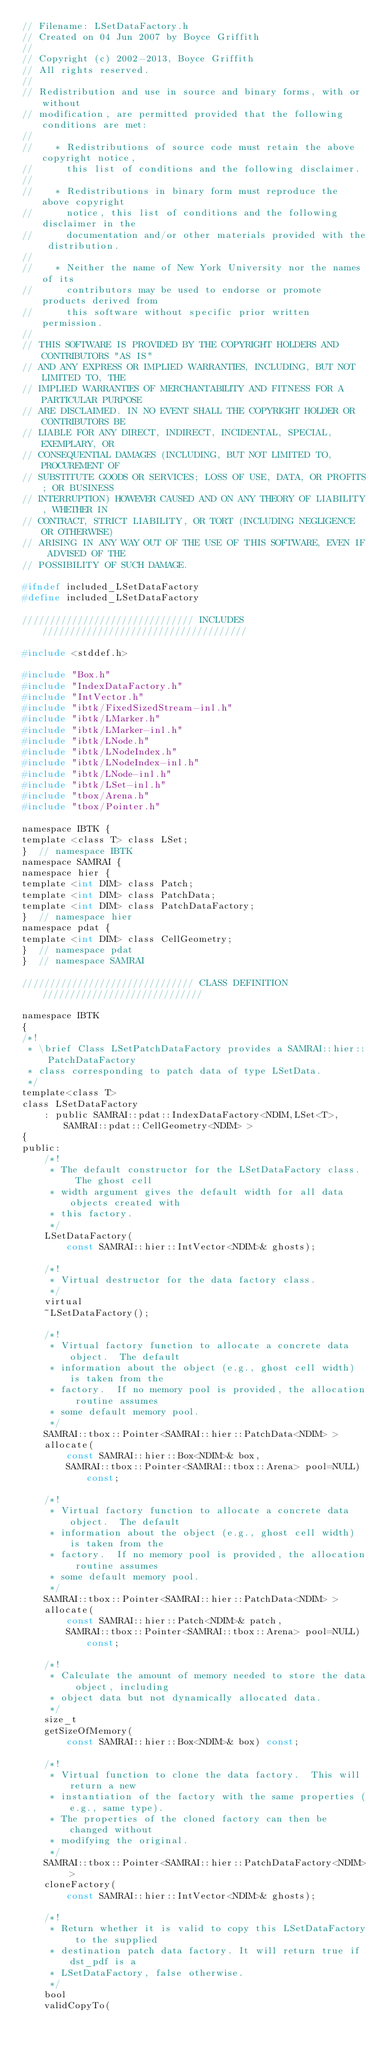<code> <loc_0><loc_0><loc_500><loc_500><_C_>// Filename: LSetDataFactory.h
// Created on 04 Jun 2007 by Boyce Griffith
//
// Copyright (c) 2002-2013, Boyce Griffith
// All rights reserved.
//
// Redistribution and use in source and binary forms, with or without
// modification, are permitted provided that the following conditions are met:
//
//    * Redistributions of source code must retain the above copyright notice,
//      this list of conditions and the following disclaimer.
//
//    * Redistributions in binary form must reproduce the above copyright
//      notice, this list of conditions and the following disclaimer in the
//      documentation and/or other materials provided with the distribution.
//
//    * Neither the name of New York University nor the names of its
//      contributors may be used to endorse or promote products derived from
//      this software without specific prior written permission.
//
// THIS SOFTWARE IS PROVIDED BY THE COPYRIGHT HOLDERS AND CONTRIBUTORS "AS IS"
// AND ANY EXPRESS OR IMPLIED WARRANTIES, INCLUDING, BUT NOT LIMITED TO, THE
// IMPLIED WARRANTIES OF MERCHANTABILITY AND FITNESS FOR A PARTICULAR PURPOSE
// ARE DISCLAIMED. IN NO EVENT SHALL THE COPYRIGHT HOLDER OR CONTRIBUTORS BE
// LIABLE FOR ANY DIRECT, INDIRECT, INCIDENTAL, SPECIAL, EXEMPLARY, OR
// CONSEQUENTIAL DAMAGES (INCLUDING, BUT NOT LIMITED TO, PROCUREMENT OF
// SUBSTITUTE GOODS OR SERVICES; LOSS OF USE, DATA, OR PROFITS; OR BUSINESS
// INTERRUPTION) HOWEVER CAUSED AND ON ANY THEORY OF LIABILITY, WHETHER IN
// CONTRACT, STRICT LIABILITY, OR TORT (INCLUDING NEGLIGENCE OR OTHERWISE)
// ARISING IN ANY WAY OUT OF THE USE OF THIS SOFTWARE, EVEN IF ADVISED OF THE
// POSSIBILITY OF SUCH DAMAGE.

#ifndef included_LSetDataFactory
#define included_LSetDataFactory

/////////////////////////////// INCLUDES /////////////////////////////////////

#include <stddef.h>

#include "Box.h"
#include "IndexDataFactory.h"
#include "IntVector.h"
#include "ibtk/FixedSizedStream-inl.h"
#include "ibtk/LMarker.h"
#include "ibtk/LMarker-inl.h"
#include "ibtk/LNode.h"
#include "ibtk/LNodeIndex.h"
#include "ibtk/LNodeIndex-inl.h"
#include "ibtk/LNode-inl.h"
#include "ibtk/LSet-inl.h"
#include "tbox/Arena.h"
#include "tbox/Pointer.h"

namespace IBTK {
template <class T> class LSet;
}  // namespace IBTK
namespace SAMRAI {
namespace hier {
template <int DIM> class Patch;
template <int DIM> class PatchData;
template <int DIM> class PatchDataFactory;
}  // namespace hier
namespace pdat {
template <int DIM> class CellGeometry;
}  // namespace pdat
}  // namespace SAMRAI

/////////////////////////////// CLASS DEFINITION /////////////////////////////

namespace IBTK
{
/*!
 * \brief Class LSetPatchDataFactory provides a SAMRAI::hier::PatchDataFactory
 * class corresponding to patch data of type LSetData.
 */
template<class T>
class LSetDataFactory
    : public SAMRAI::pdat::IndexDataFactory<NDIM,LSet<T>,SAMRAI::pdat::CellGeometry<NDIM> >
{
public:
    /*!
     * The default constructor for the LSetDataFactory class.  The ghost cell
     * width argument gives the default width for all data objects created with
     * this factory.
     */
    LSetDataFactory(
        const SAMRAI::hier::IntVector<NDIM>& ghosts);

    /*!
     * Virtual destructor for the data factory class.
     */
    virtual
    ~LSetDataFactory();

    /*!
     * Virtual factory function to allocate a concrete data object.  The default
     * information about the object (e.g., ghost cell width) is taken from the
     * factory.  If no memory pool is provided, the allocation routine assumes
     * some default memory pool.
     */
    SAMRAI::tbox::Pointer<SAMRAI::hier::PatchData<NDIM> >
    allocate(
        const SAMRAI::hier::Box<NDIM>& box,
        SAMRAI::tbox::Pointer<SAMRAI::tbox::Arena> pool=NULL) const;

    /*!
     * Virtual factory function to allocate a concrete data object.  The default
     * information about the object (e.g., ghost cell width) is taken from the
     * factory.  If no memory pool is provided, the allocation routine assumes
     * some default memory pool.
     */
    SAMRAI::tbox::Pointer<SAMRAI::hier::PatchData<NDIM> >
    allocate(
        const SAMRAI::hier::Patch<NDIM>& patch,
        SAMRAI::tbox::Pointer<SAMRAI::tbox::Arena> pool=NULL) const;

    /*!
     * Calculate the amount of memory needed to store the data object, including
     * object data but not dynamically allocated data.
     */
    size_t
    getSizeOfMemory(
        const SAMRAI::hier::Box<NDIM>& box) const;

    /*!
     * Virtual function to clone the data factory.  This will return a new
     * instantiation of the factory with the same properties (e.g., same type).
     * The properties of the cloned factory can then be changed without
     * modifying the original.
     */
    SAMRAI::tbox::Pointer<SAMRAI::hier::PatchDataFactory<NDIM> >
    cloneFactory(
        const SAMRAI::hier::IntVector<NDIM>& ghosts);

    /*!
     * Return whether it is valid to copy this LSetDataFactory to the supplied
     * destination patch data factory. It will return true if dst_pdf is a
     * LSetDataFactory, false otherwise.
     */
    bool
    validCopyTo(</code> 